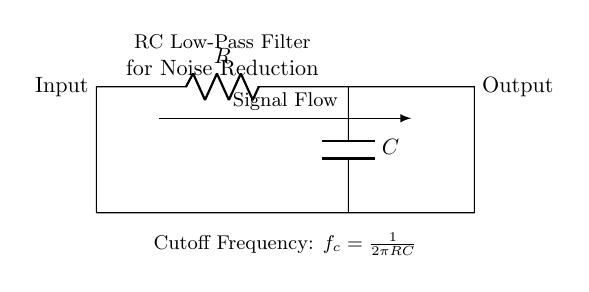What are the components in this circuit? The circuit contains a resistor and a capacitor, which are common components in an RC filter. They are essential for determining the circuit's behavior regarding noise reduction.
Answer: Resistor, Capacitor What is the function of the resistor in this circuit? The resistor limits the current flowing into the capacitor and sets the time constant for the charging and discharging process, which influences the filter's effectiveness in noise reduction.
Answer: Current limiting What does the arrow represent in the signal flow? The arrow indicates the direction of signal flow from the input through the resistor and capacitor to the output, showing how the audio signal is processed to reduce noise.
Answer: Signal direction How do you calculate the cutoff frequency? The formula for the cutoff frequency is provided as \( f_c = \frac{1}{2\pi RC} \), where R is the resistance and C is the capacitance. This frequency determines at what point the audio signal begins to attenuate.
Answer: One over two pi R C What type of filter is this circuit? This is an RC low-pass filter, as it allows low frequencies to pass through while attenuating higher frequencies, effectively reducing noise in audio recordings.
Answer: Low-pass What happens to high-frequency signals in this circuit? High-frequency signals are attenuated or reduced in amplitude as they pass through the circuit, which helps improve audio quality by removing unwanted noise from recordings.
Answer: Attenuated What is the significance of the capacitor in this circuit? The capacitor stores and releases energy, smoothing out the fluctuations in voltage and effectively filtering out high-frequency noise from the audio signal.
Answer: Smoothing 